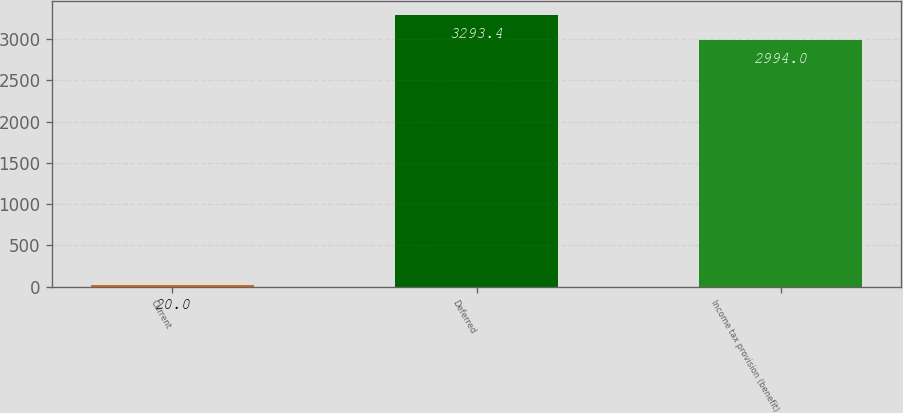Convert chart to OTSL. <chart><loc_0><loc_0><loc_500><loc_500><bar_chart><fcel>Current<fcel>Deferred<fcel>Income tax provision (benefit)<nl><fcel>20<fcel>3293.4<fcel>2994<nl></chart> 